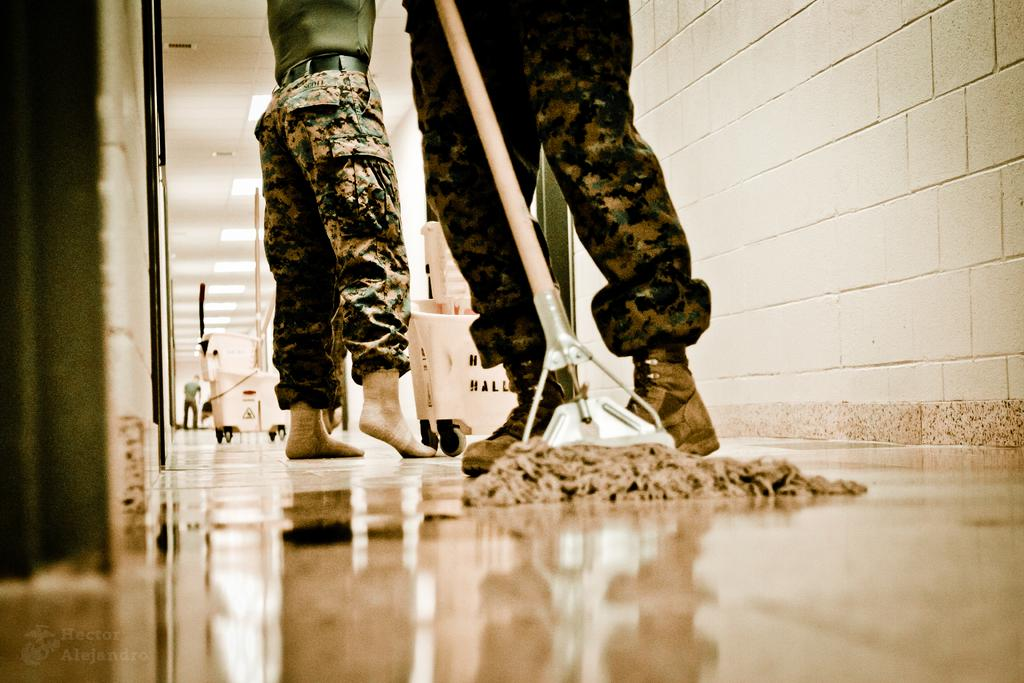What is happening in the image? There are people standing in the image. What can be seen in the corridor of the building? There are cleaning objects in the corridor of the building. What type of structure is shown in the image? The image shows a building. How many babies are present in the image? There are no babies present in the image. What type of mailbox can be seen in the image? There is no mailbox present in the image. 